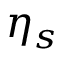Convert formula to latex. <formula><loc_0><loc_0><loc_500><loc_500>\eta _ { s }</formula> 